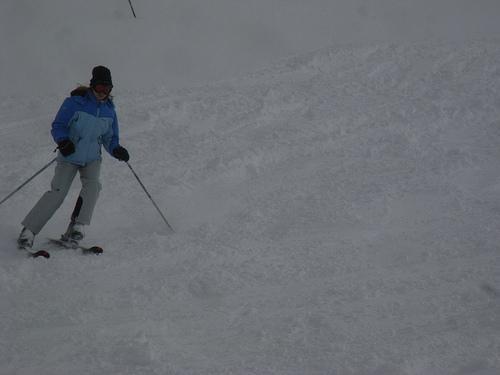How many ski poles does the woman hold?
Give a very brief answer. 2. How many shades of blue are on the woman's coat?
Give a very brief answer. 2. 